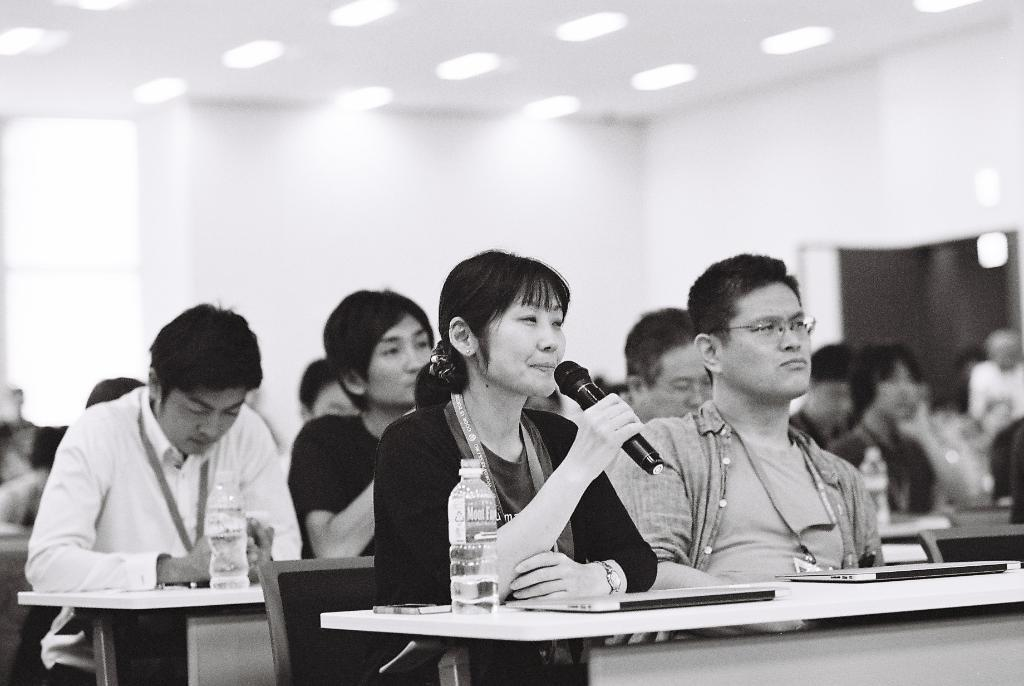How many people are in the image? There is a group of people in the image. What are the people doing in the image? The people are sitting on chairs and at their tables. What can be seen on the tables in the image? There are water bottles and files on the tables. What is the woman holding in her hand? The woman is holding a mic in her hand. What type of collar can be seen on the page in the image? There is no page or collar present in the image. 